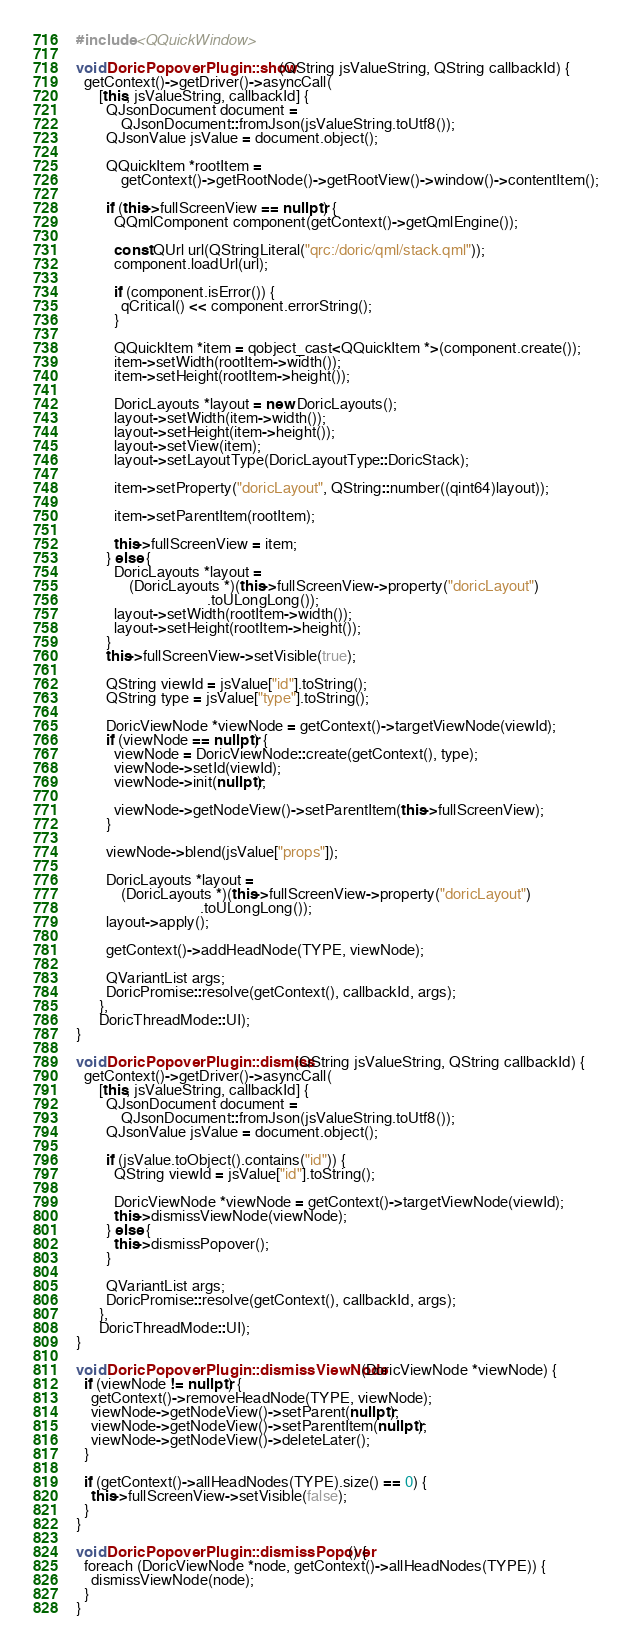Convert code to text. <code><loc_0><loc_0><loc_500><loc_500><_C++_>#include <QQuickWindow>

void DoricPopoverPlugin::show(QString jsValueString, QString callbackId) {
  getContext()->getDriver()->asyncCall(
      [this, jsValueString, callbackId] {
        QJsonDocument document =
            QJsonDocument::fromJson(jsValueString.toUtf8());
        QJsonValue jsValue = document.object();

        QQuickItem *rootItem =
            getContext()->getRootNode()->getRootView()->window()->contentItem();

        if (this->fullScreenView == nullptr) {
          QQmlComponent component(getContext()->getQmlEngine());

          const QUrl url(QStringLiteral("qrc:/doric/qml/stack.qml"));
          component.loadUrl(url);

          if (component.isError()) {
            qCritical() << component.errorString();
          }

          QQuickItem *item = qobject_cast<QQuickItem *>(component.create());
          item->setWidth(rootItem->width());
          item->setHeight(rootItem->height());

          DoricLayouts *layout = new DoricLayouts();
          layout->setWidth(item->width());
          layout->setHeight(item->height());
          layout->setView(item);
          layout->setLayoutType(DoricLayoutType::DoricStack);

          item->setProperty("doricLayout", QString::number((qint64)layout));

          item->setParentItem(rootItem);

          this->fullScreenView = item;
        } else {
          DoricLayouts *layout =
              (DoricLayouts *)(this->fullScreenView->property("doricLayout")
                                   .toULongLong());
          layout->setWidth(rootItem->width());
          layout->setHeight(rootItem->height());
        }
        this->fullScreenView->setVisible(true);

        QString viewId = jsValue["id"].toString();
        QString type = jsValue["type"].toString();

        DoricViewNode *viewNode = getContext()->targetViewNode(viewId);
        if (viewNode == nullptr) {
          viewNode = DoricViewNode::create(getContext(), type);
          viewNode->setId(viewId);
          viewNode->init(nullptr);

          viewNode->getNodeView()->setParentItem(this->fullScreenView);
        }

        viewNode->blend(jsValue["props"]);

        DoricLayouts *layout =
            (DoricLayouts *)(this->fullScreenView->property("doricLayout")
                                 .toULongLong());
        layout->apply();

        getContext()->addHeadNode(TYPE, viewNode);

        QVariantList args;
        DoricPromise::resolve(getContext(), callbackId, args);
      },
      DoricThreadMode::UI);
}

void DoricPopoverPlugin::dismiss(QString jsValueString, QString callbackId) {
  getContext()->getDriver()->asyncCall(
      [this, jsValueString, callbackId] {
        QJsonDocument document =
            QJsonDocument::fromJson(jsValueString.toUtf8());
        QJsonValue jsValue = document.object();

        if (jsValue.toObject().contains("id")) {
          QString viewId = jsValue["id"].toString();

          DoricViewNode *viewNode = getContext()->targetViewNode(viewId);
          this->dismissViewNode(viewNode);
        } else {
          this->dismissPopover();
        }

        QVariantList args;
        DoricPromise::resolve(getContext(), callbackId, args);
      },
      DoricThreadMode::UI);
}

void DoricPopoverPlugin::dismissViewNode(DoricViewNode *viewNode) {
  if (viewNode != nullptr) {
    getContext()->removeHeadNode(TYPE, viewNode);
    viewNode->getNodeView()->setParent(nullptr);
    viewNode->getNodeView()->setParentItem(nullptr);
    viewNode->getNodeView()->deleteLater();
  }

  if (getContext()->allHeadNodes(TYPE).size() == 0) {
    this->fullScreenView->setVisible(false);
  }
}

void DoricPopoverPlugin::dismissPopover() {
  foreach (DoricViewNode *node, getContext()->allHeadNodes(TYPE)) {
    dismissViewNode(node);
  }
}
</code> 